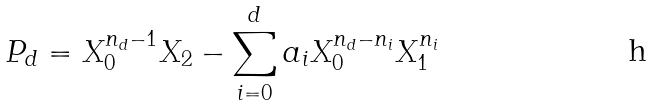Convert formula to latex. <formula><loc_0><loc_0><loc_500><loc_500>P _ { d } = X _ { 0 } ^ { n _ { d } - 1 } X _ { 2 } - \sum _ { i = 0 } ^ { d } a _ { i } X _ { 0 } ^ { n _ { d } - n _ { i } } X _ { 1 } ^ { n _ { i } }</formula> 